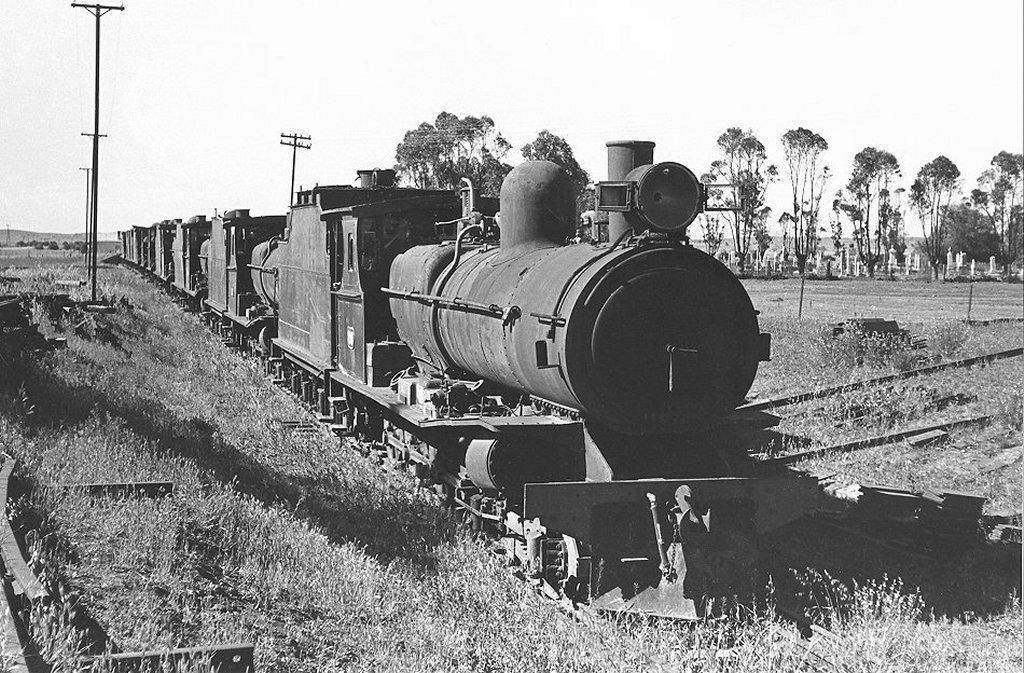What is the color scheme of the image? The image is black and white. What can be seen on the track in the image? There is a train on the track in the image. What objects are on the grass in the image? There are poles on the grass in the image. What is visible in the background of the image? There are trees and the sky in the background of the image. What type of destruction can be seen in the image? There is no destruction present in the image; it features a train on a track, poles on the grass, and trees and sky in the background. Can you see any fairies flying around the train in the image? There are no fairies present in the image. 